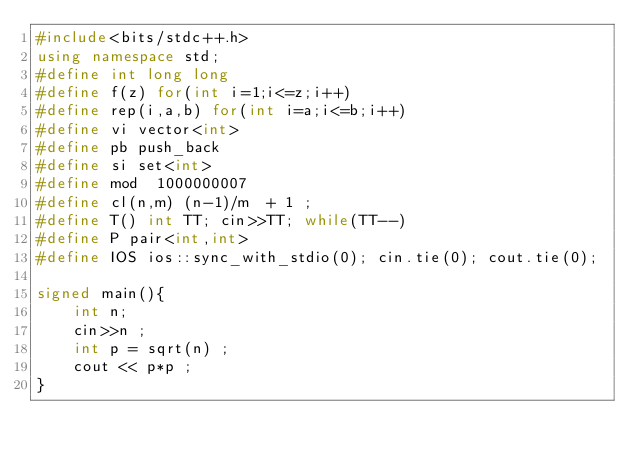<code> <loc_0><loc_0><loc_500><loc_500><_C++_>#include<bits/stdc++.h>
using namespace std;
#define int long long
#define f(z) for(int i=1;i<=z;i++)
#define rep(i,a,b) for(int i=a;i<=b;i++)
#define vi vector<int>
#define pb push_back
#define si set<int>
#define mod  1000000007
#define cl(n,m) (n-1)/m  + 1 ;
#define T() int TT; cin>>TT; while(TT--)
#define P pair<int,int>
#define IOS ios::sync_with_stdio(0); cin.tie(0); cout.tie(0);

signed main(){
	int n; 
	cin>>n ;
	int p = sqrt(n) ;
	cout << p*p ;
}
</code> 